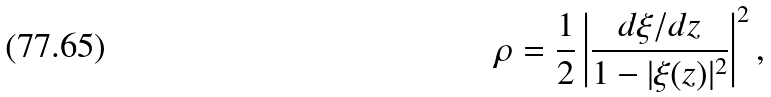<formula> <loc_0><loc_0><loc_500><loc_500>\rho = \frac { 1 } { 2 } \left | \frac { d \xi / d z } { 1 - | \xi ( z ) | ^ { 2 } } \right | ^ { 2 } ,</formula> 